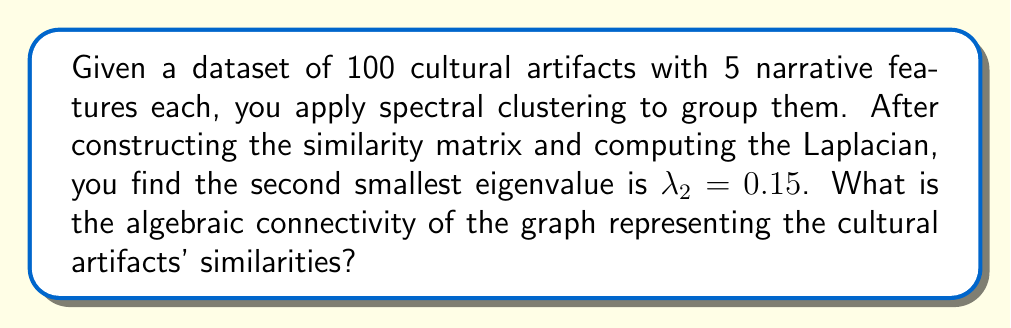Provide a solution to this math problem. To solve this problem, we need to understand the concept of algebraic connectivity in spectral clustering:

1) In spectral clustering, we represent the dataset as a graph, where each node is a data point (cultural artifact) and edges represent similarities between them.

2) The Laplacian matrix $L$ of this graph is computed, which encodes the graph's structure.

3) The eigenvalues of the Laplacian matrix provide important information about the graph's connectivity.

4) The second smallest eigenvalue of the Laplacian is known as the algebraic connectivity or Fiedler value.

5) This value is denoted as $\lambda_2$ and is always non-negative for a connected graph.

6) The algebraic connectivity provides a measure of how well-connected the graph is. A larger value indicates a more connected graph, while a value close to zero suggests the graph is close to being disconnected.

7) In this case, we are given that $\lambda_2 = 0.15$.

8) The algebraic connectivity is exactly this value, $\lambda_2$.

Therefore, the algebraic connectivity of the graph representing the cultural artifacts' similarities is 0.15.
Answer: 0.15 